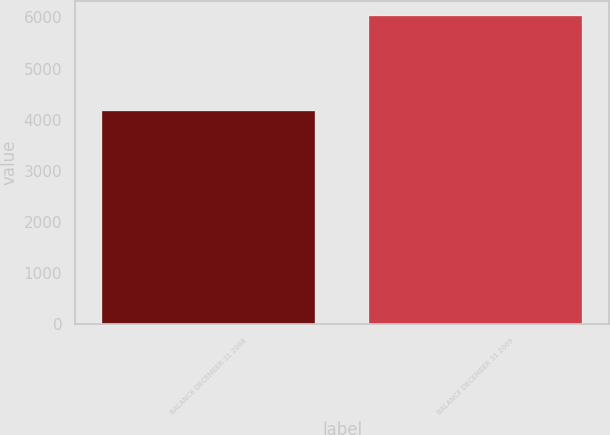Convert chart to OTSL. <chart><loc_0><loc_0><loc_500><loc_500><bar_chart><fcel>BALANCE DECEMBER 31 2008<fcel>BALANCE DECEMBER 31 2009<nl><fcel>4169<fcel>6023<nl></chart> 